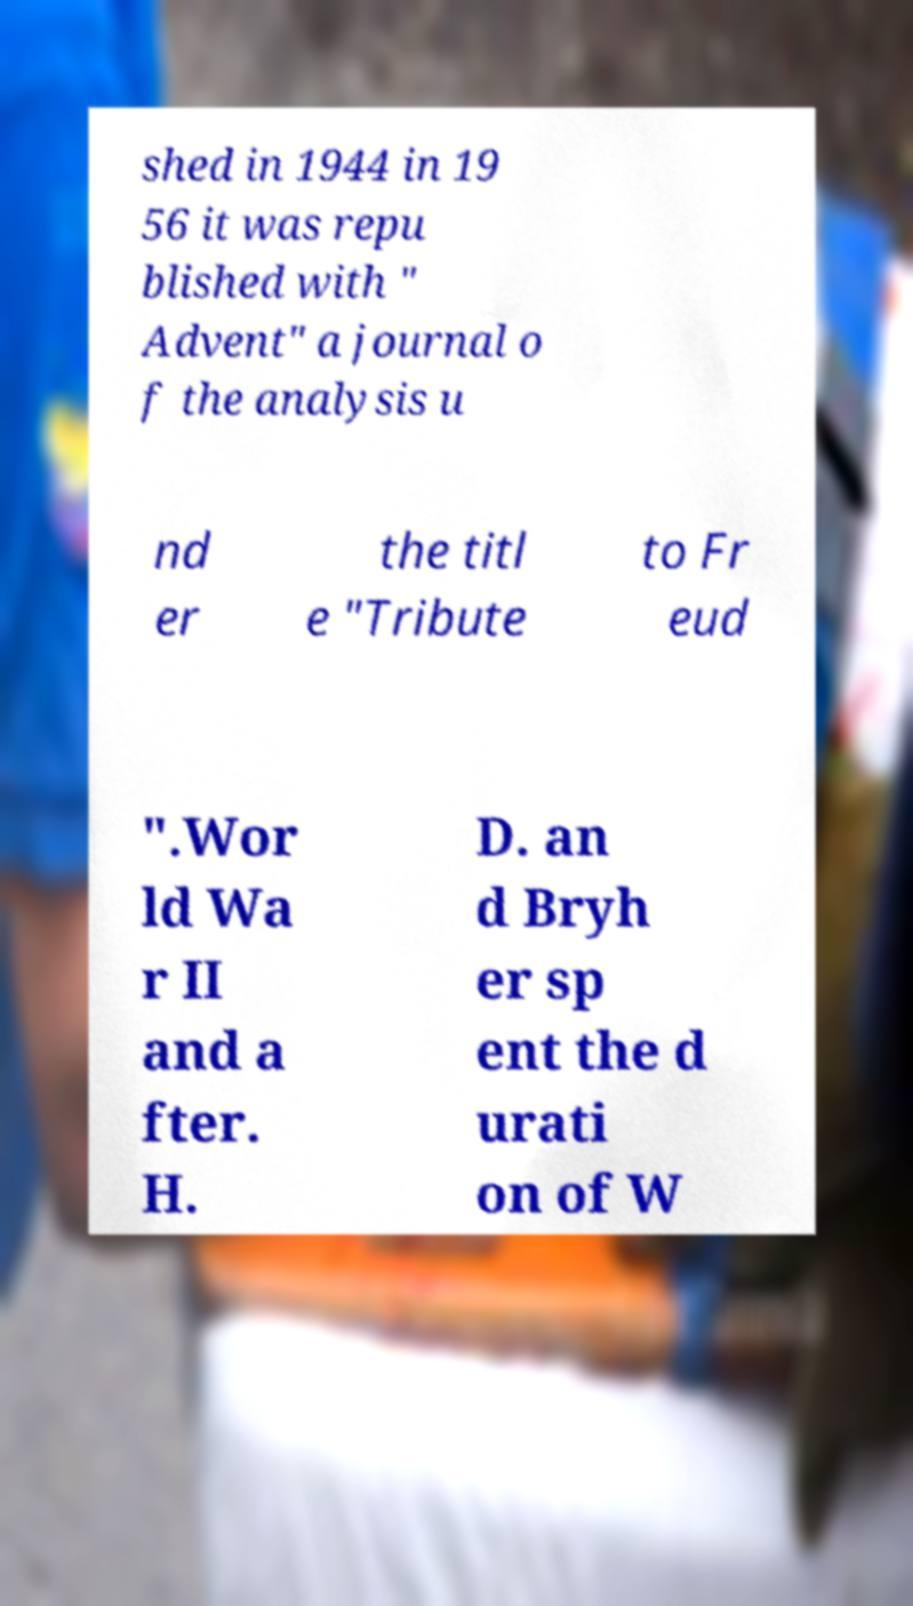Could you assist in decoding the text presented in this image and type it out clearly? shed in 1944 in 19 56 it was repu blished with " Advent" a journal o f the analysis u nd er the titl e "Tribute to Fr eud ".Wor ld Wa r II and a fter. H. D. an d Bryh er sp ent the d urati on of W 